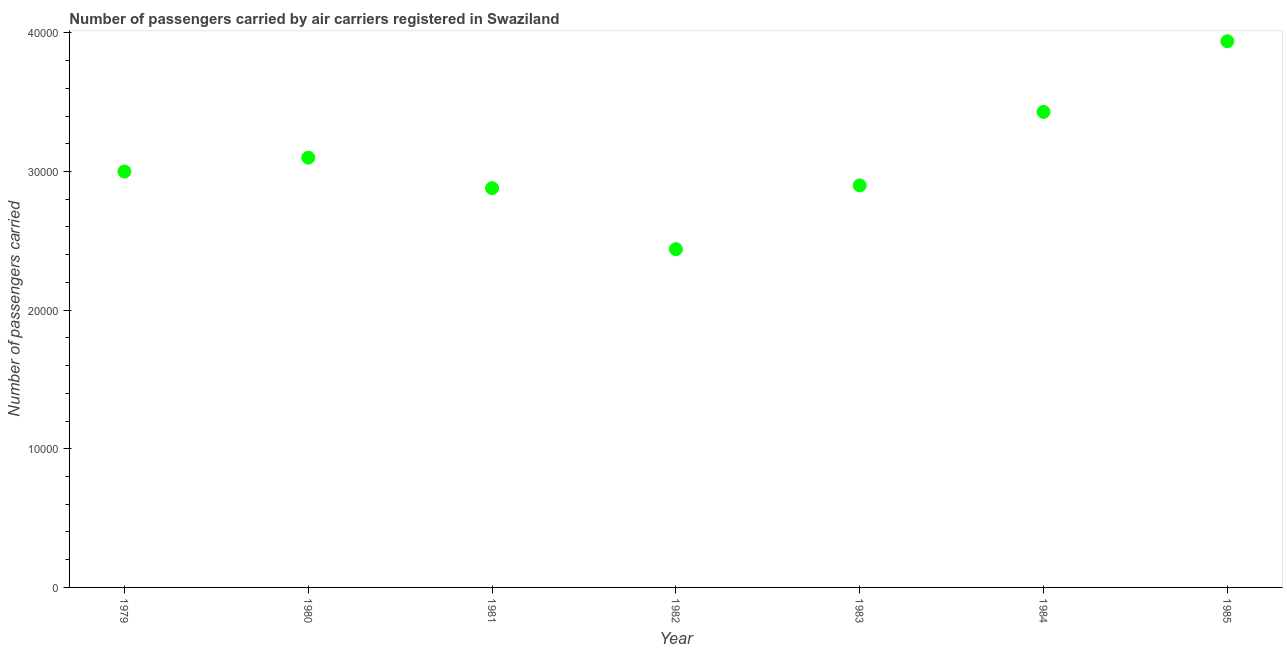What is the number of passengers carried in 1984?
Provide a succinct answer. 3.43e+04. Across all years, what is the maximum number of passengers carried?
Provide a short and direct response. 3.94e+04. Across all years, what is the minimum number of passengers carried?
Give a very brief answer. 2.44e+04. In which year was the number of passengers carried minimum?
Provide a succinct answer. 1982. What is the sum of the number of passengers carried?
Your answer should be compact. 2.17e+05. What is the difference between the number of passengers carried in 1981 and 1983?
Offer a very short reply. -200. What is the average number of passengers carried per year?
Provide a short and direct response. 3.10e+04. What is the median number of passengers carried?
Make the answer very short. 3.00e+04. What is the ratio of the number of passengers carried in 1979 to that in 1982?
Provide a short and direct response. 1.23. What is the difference between the highest and the second highest number of passengers carried?
Your answer should be compact. 5100. What is the difference between the highest and the lowest number of passengers carried?
Provide a succinct answer. 1.50e+04. Does the number of passengers carried monotonically increase over the years?
Offer a terse response. No. How many dotlines are there?
Give a very brief answer. 1. How many years are there in the graph?
Your response must be concise. 7. Are the values on the major ticks of Y-axis written in scientific E-notation?
Offer a very short reply. No. Does the graph contain any zero values?
Your answer should be compact. No. Does the graph contain grids?
Offer a very short reply. No. What is the title of the graph?
Provide a succinct answer. Number of passengers carried by air carriers registered in Swaziland. What is the label or title of the Y-axis?
Provide a succinct answer. Number of passengers carried. What is the Number of passengers carried in 1979?
Offer a very short reply. 3.00e+04. What is the Number of passengers carried in 1980?
Provide a short and direct response. 3.10e+04. What is the Number of passengers carried in 1981?
Your answer should be compact. 2.88e+04. What is the Number of passengers carried in 1982?
Provide a succinct answer. 2.44e+04. What is the Number of passengers carried in 1983?
Your answer should be very brief. 2.90e+04. What is the Number of passengers carried in 1984?
Your answer should be very brief. 3.43e+04. What is the Number of passengers carried in 1985?
Give a very brief answer. 3.94e+04. What is the difference between the Number of passengers carried in 1979 and 1980?
Provide a short and direct response. -1000. What is the difference between the Number of passengers carried in 1979 and 1981?
Provide a succinct answer. 1200. What is the difference between the Number of passengers carried in 1979 and 1982?
Ensure brevity in your answer.  5600. What is the difference between the Number of passengers carried in 1979 and 1983?
Offer a very short reply. 1000. What is the difference between the Number of passengers carried in 1979 and 1984?
Give a very brief answer. -4300. What is the difference between the Number of passengers carried in 1979 and 1985?
Provide a short and direct response. -9400. What is the difference between the Number of passengers carried in 1980 and 1981?
Keep it short and to the point. 2200. What is the difference between the Number of passengers carried in 1980 and 1982?
Provide a short and direct response. 6600. What is the difference between the Number of passengers carried in 1980 and 1984?
Give a very brief answer. -3300. What is the difference between the Number of passengers carried in 1980 and 1985?
Ensure brevity in your answer.  -8400. What is the difference between the Number of passengers carried in 1981 and 1982?
Provide a succinct answer. 4400. What is the difference between the Number of passengers carried in 1981 and 1983?
Give a very brief answer. -200. What is the difference between the Number of passengers carried in 1981 and 1984?
Make the answer very short. -5500. What is the difference between the Number of passengers carried in 1981 and 1985?
Your answer should be compact. -1.06e+04. What is the difference between the Number of passengers carried in 1982 and 1983?
Keep it short and to the point. -4600. What is the difference between the Number of passengers carried in 1982 and 1984?
Offer a terse response. -9900. What is the difference between the Number of passengers carried in 1982 and 1985?
Offer a very short reply. -1.50e+04. What is the difference between the Number of passengers carried in 1983 and 1984?
Offer a terse response. -5300. What is the difference between the Number of passengers carried in 1983 and 1985?
Provide a succinct answer. -1.04e+04. What is the difference between the Number of passengers carried in 1984 and 1985?
Provide a succinct answer. -5100. What is the ratio of the Number of passengers carried in 1979 to that in 1980?
Give a very brief answer. 0.97. What is the ratio of the Number of passengers carried in 1979 to that in 1981?
Provide a succinct answer. 1.04. What is the ratio of the Number of passengers carried in 1979 to that in 1982?
Offer a terse response. 1.23. What is the ratio of the Number of passengers carried in 1979 to that in 1983?
Your answer should be compact. 1.03. What is the ratio of the Number of passengers carried in 1979 to that in 1984?
Provide a short and direct response. 0.88. What is the ratio of the Number of passengers carried in 1979 to that in 1985?
Ensure brevity in your answer.  0.76. What is the ratio of the Number of passengers carried in 1980 to that in 1981?
Offer a very short reply. 1.08. What is the ratio of the Number of passengers carried in 1980 to that in 1982?
Your response must be concise. 1.27. What is the ratio of the Number of passengers carried in 1980 to that in 1983?
Provide a short and direct response. 1.07. What is the ratio of the Number of passengers carried in 1980 to that in 1984?
Provide a succinct answer. 0.9. What is the ratio of the Number of passengers carried in 1980 to that in 1985?
Offer a terse response. 0.79. What is the ratio of the Number of passengers carried in 1981 to that in 1982?
Ensure brevity in your answer.  1.18. What is the ratio of the Number of passengers carried in 1981 to that in 1984?
Offer a very short reply. 0.84. What is the ratio of the Number of passengers carried in 1981 to that in 1985?
Offer a terse response. 0.73. What is the ratio of the Number of passengers carried in 1982 to that in 1983?
Offer a very short reply. 0.84. What is the ratio of the Number of passengers carried in 1982 to that in 1984?
Offer a very short reply. 0.71. What is the ratio of the Number of passengers carried in 1982 to that in 1985?
Your answer should be compact. 0.62. What is the ratio of the Number of passengers carried in 1983 to that in 1984?
Make the answer very short. 0.84. What is the ratio of the Number of passengers carried in 1983 to that in 1985?
Offer a terse response. 0.74. What is the ratio of the Number of passengers carried in 1984 to that in 1985?
Offer a very short reply. 0.87. 